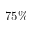Convert formula to latex. <formula><loc_0><loc_0><loc_500><loc_500>7 5 \%</formula> 